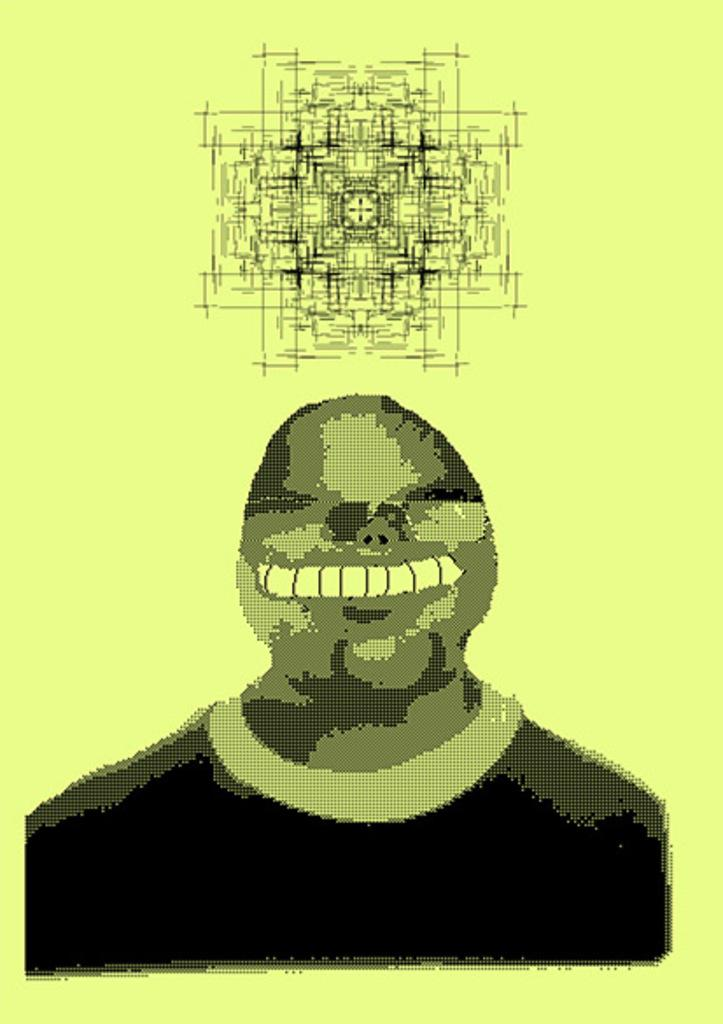What is depicted in the image? There is a person illustration in the image. What else can be seen in the image besides the person illustration? There is a sketch in the image. How many chairs are visible in the image? There are no chairs present in the image. What type of stone is used to create the person illustration in the image? The person illustration is not made of stone; it is likely a drawing or illustration. 